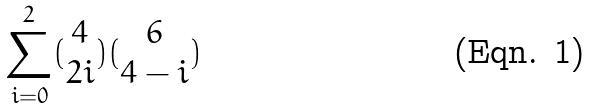Convert formula to latex. <formula><loc_0><loc_0><loc_500><loc_500>\sum _ { i = 0 } ^ { 2 } ( \begin{matrix} 4 \\ 2 i \end{matrix} ) ( \begin{matrix} 6 \\ 4 - i \end{matrix} )</formula> 